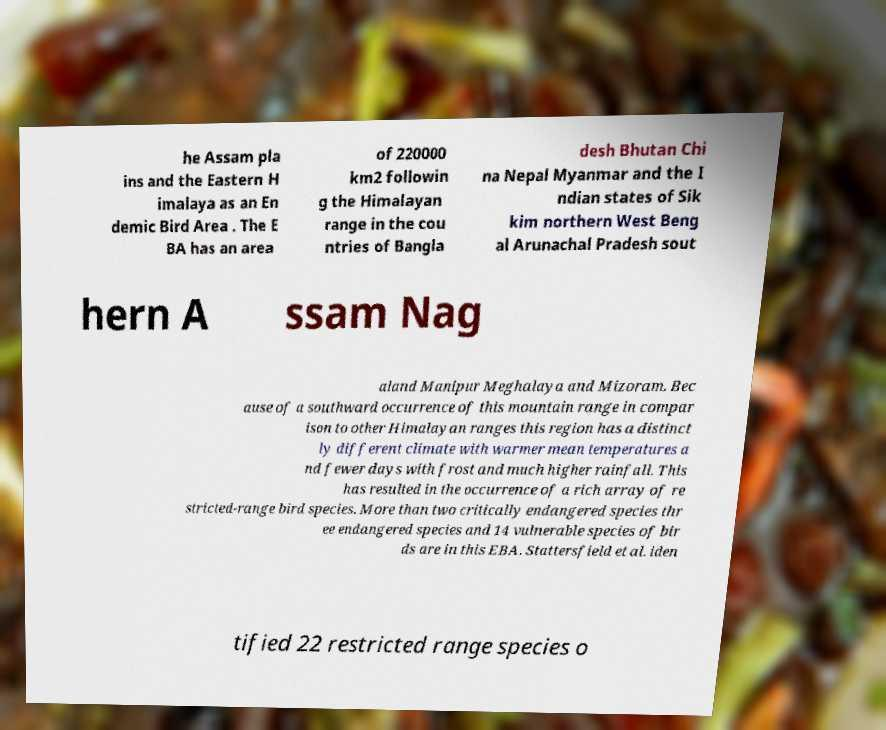Can you accurately transcribe the text from the provided image for me? he Assam pla ins and the Eastern H imalaya as an En demic Bird Area . The E BA has an area of 220000 km2 followin g the Himalayan range in the cou ntries of Bangla desh Bhutan Chi na Nepal Myanmar and the I ndian states of Sik kim northern West Beng al Arunachal Pradesh sout hern A ssam Nag aland Manipur Meghalaya and Mizoram. Bec ause of a southward occurrence of this mountain range in compar ison to other Himalayan ranges this region has a distinct ly different climate with warmer mean temperatures a nd fewer days with frost and much higher rainfall. This has resulted in the occurrence of a rich array of re stricted-range bird species. More than two critically endangered species thr ee endangered species and 14 vulnerable species of bir ds are in this EBA. Stattersfield et al. iden tified 22 restricted range species o 